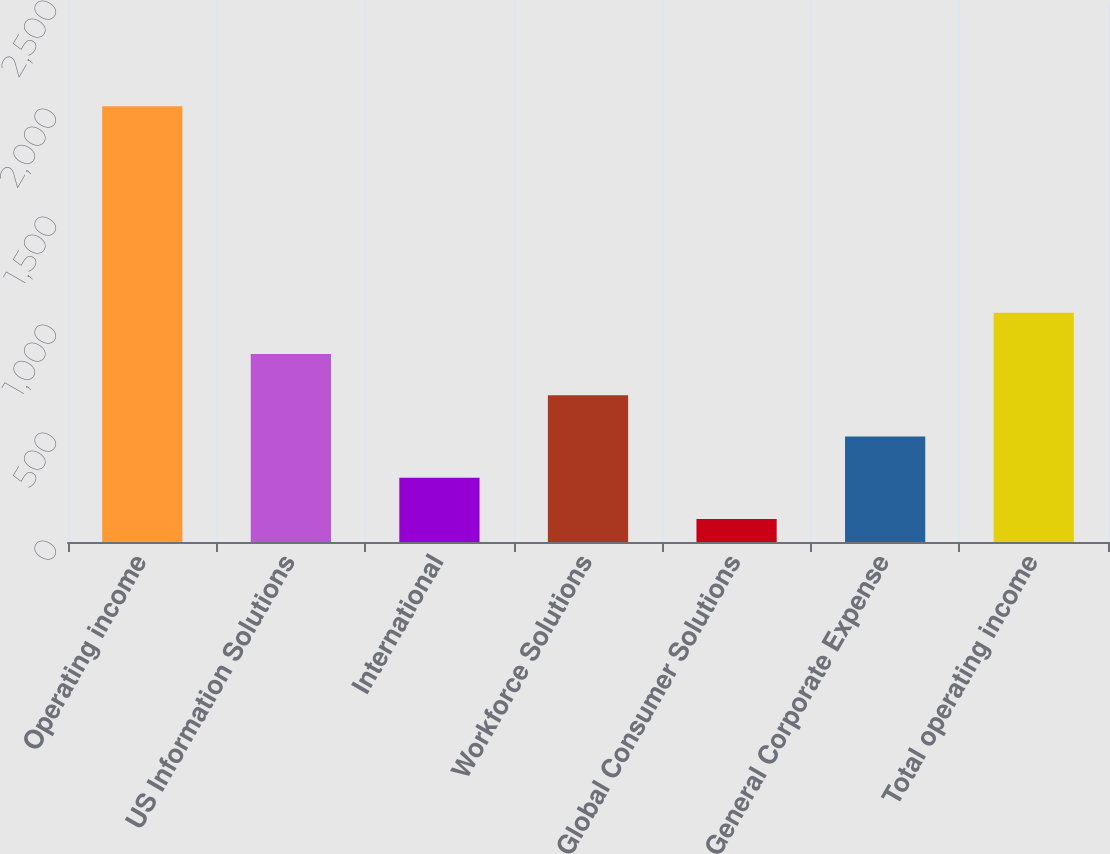Convert chart to OTSL. <chart><loc_0><loc_0><loc_500><loc_500><bar_chart><fcel>Operating income<fcel>US Information Solutions<fcel>International<fcel>Workforce Solutions<fcel>Global Consumer Solutions<fcel>General Corporate Expense<fcel>Total operating income<nl><fcel>2017<fcel>870.52<fcel>297.28<fcel>679.44<fcel>106.2<fcel>488.36<fcel>1061.6<nl></chart> 